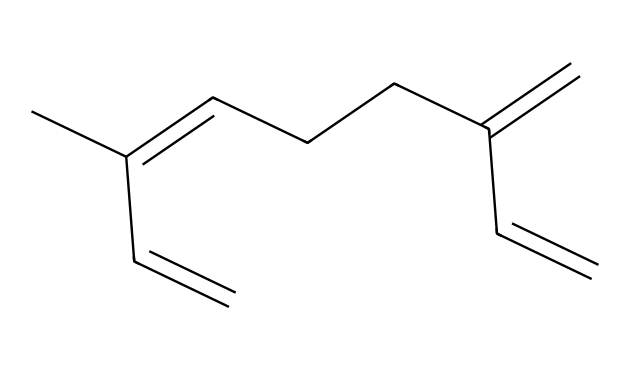What is the common name for this chemical? The SMILES representation indicates a compound that corresponds to myrcene, which is a recognized terpene often found in various plants and fruits, including mangoes.
Answer: myrcene How many carbon atoms are in myrcene? By analyzing the SMILES structure, we can count the carbon atoms denoted by "C". The structure shows 10 carbon atoms present in total.
Answer: 10 What type of chemical compound is myrcene classified as? Myrcene is classified as a terpene, which is defined by its structure that includes a series of carbon chains with double bonds. This categorization reflects its role in the aromatic properties of plants.
Answer: terpene What is the degree of unsaturation in myrcene? The degree of unsaturation can be calculated by looking at the number of double bonds and rings in the structure. In myrcene, there are three double bonds, which contribute to a higher degree of unsaturation than a fully saturated alkane.
Answer: 3 Which functional group is prominent in myrcene? Myrcene contains multiple double bonds (alkene functional groups), which can be identified in the SMILES by looking for the "=" symbols representing the bonds.
Answer: alkene What is the structure characteristic of terpenes that myrcene exhibits? Myrcene exhibits a hydrocarbon structure characterized by a non-cyclic arrangement of carbon atoms with multiple double bonds, typical of many terpenes which are known for their diverse shapes and angles.
Answer: linear-chain 